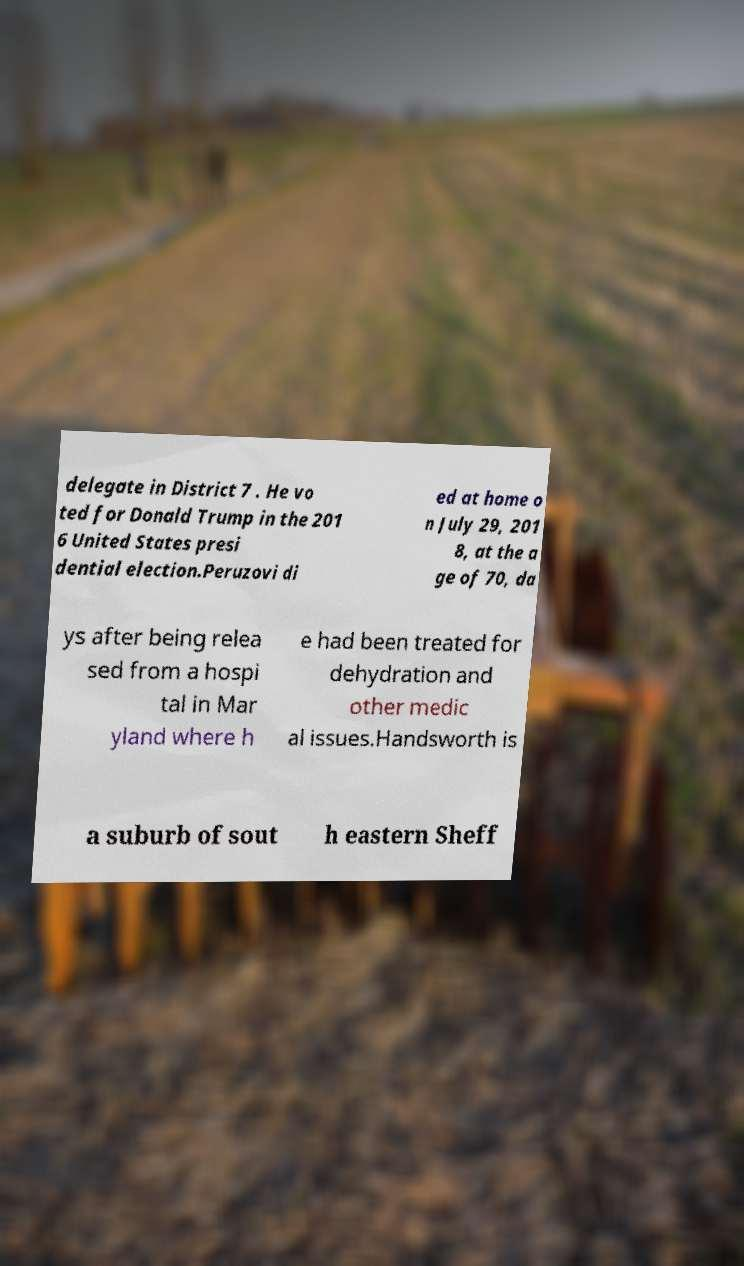Please identify and transcribe the text found in this image. delegate in District 7 . He vo ted for Donald Trump in the 201 6 United States presi dential election.Peruzovi di ed at home o n July 29, 201 8, at the a ge of 70, da ys after being relea sed from a hospi tal in Mar yland where h e had been treated for dehydration and other medic al issues.Handsworth is a suburb of sout h eastern Sheff 